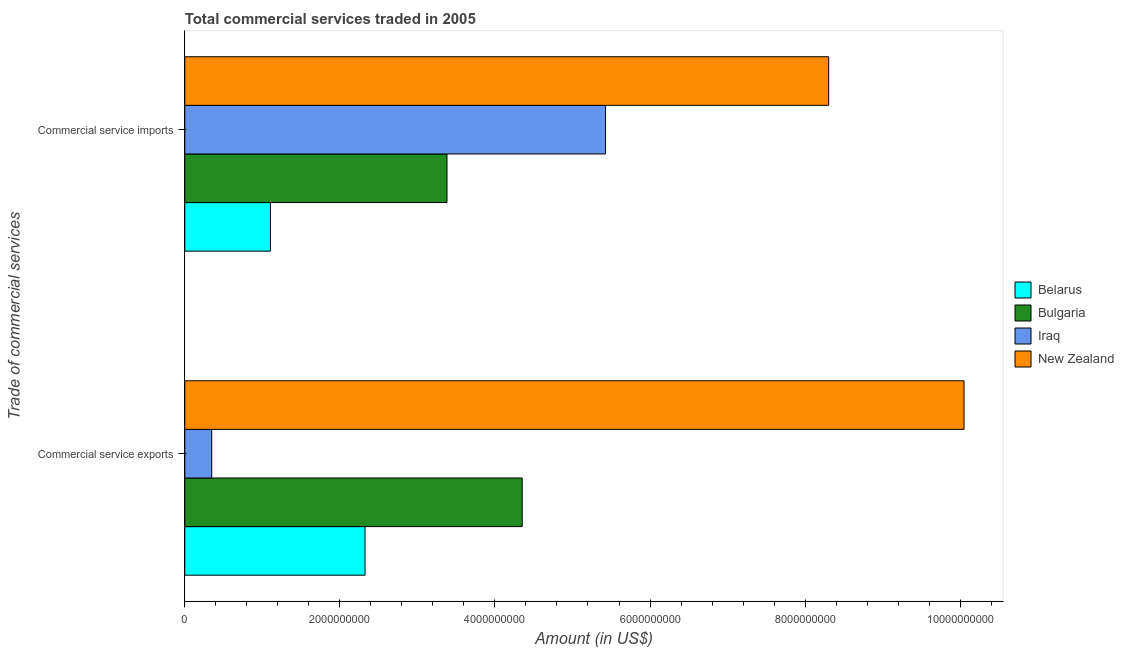How many groups of bars are there?
Offer a terse response. 2. Are the number of bars per tick equal to the number of legend labels?
Provide a succinct answer. Yes. How many bars are there on the 1st tick from the bottom?
Provide a short and direct response. 4. What is the label of the 2nd group of bars from the top?
Keep it short and to the point. Commercial service exports. What is the amount of commercial service imports in Bulgaria?
Make the answer very short. 3.38e+09. Across all countries, what is the maximum amount of commercial service exports?
Make the answer very short. 1.00e+1. Across all countries, what is the minimum amount of commercial service imports?
Your answer should be very brief. 1.10e+09. In which country was the amount of commercial service imports maximum?
Ensure brevity in your answer.  New Zealand. In which country was the amount of commercial service exports minimum?
Keep it short and to the point. Iraq. What is the total amount of commercial service imports in the graph?
Offer a very short reply. 1.82e+1. What is the difference between the amount of commercial service imports in New Zealand and that in Belarus?
Provide a succinct answer. 7.20e+09. What is the difference between the amount of commercial service imports in Bulgaria and the amount of commercial service exports in New Zealand?
Your answer should be very brief. -6.67e+09. What is the average amount of commercial service imports per country?
Offer a very short reply. 4.55e+09. What is the difference between the amount of commercial service imports and amount of commercial service exports in Iraq?
Ensure brevity in your answer.  5.08e+09. In how many countries, is the amount of commercial service exports greater than 4000000000 US$?
Make the answer very short. 2. What is the ratio of the amount of commercial service imports in Iraq to that in Belarus?
Ensure brevity in your answer.  4.91. In how many countries, is the amount of commercial service imports greater than the average amount of commercial service imports taken over all countries?
Offer a very short reply. 2. What does the 4th bar from the top in Commercial service imports represents?
Ensure brevity in your answer.  Belarus. What does the 2nd bar from the bottom in Commercial service exports represents?
Give a very brief answer. Bulgaria. Are all the bars in the graph horizontal?
Provide a short and direct response. Yes. Are the values on the major ticks of X-axis written in scientific E-notation?
Offer a terse response. No. How many legend labels are there?
Your answer should be compact. 4. How are the legend labels stacked?
Give a very brief answer. Vertical. What is the title of the graph?
Your answer should be very brief. Total commercial services traded in 2005. What is the label or title of the X-axis?
Offer a very short reply. Amount (in US$). What is the label or title of the Y-axis?
Keep it short and to the point. Trade of commercial services. What is the Amount (in US$) in Belarus in Commercial service exports?
Provide a short and direct response. 2.32e+09. What is the Amount (in US$) in Bulgaria in Commercial service exports?
Provide a succinct answer. 4.35e+09. What is the Amount (in US$) in Iraq in Commercial service exports?
Provide a succinct answer. 3.48e+08. What is the Amount (in US$) of New Zealand in Commercial service exports?
Keep it short and to the point. 1.00e+1. What is the Amount (in US$) of Belarus in Commercial service imports?
Offer a very short reply. 1.10e+09. What is the Amount (in US$) in Bulgaria in Commercial service imports?
Make the answer very short. 3.38e+09. What is the Amount (in US$) in Iraq in Commercial service imports?
Make the answer very short. 5.43e+09. What is the Amount (in US$) of New Zealand in Commercial service imports?
Your response must be concise. 8.30e+09. Across all Trade of commercial services, what is the maximum Amount (in US$) of Belarus?
Offer a terse response. 2.32e+09. Across all Trade of commercial services, what is the maximum Amount (in US$) of Bulgaria?
Your response must be concise. 4.35e+09. Across all Trade of commercial services, what is the maximum Amount (in US$) in Iraq?
Provide a short and direct response. 5.43e+09. Across all Trade of commercial services, what is the maximum Amount (in US$) in New Zealand?
Offer a very short reply. 1.00e+1. Across all Trade of commercial services, what is the minimum Amount (in US$) in Belarus?
Your response must be concise. 1.10e+09. Across all Trade of commercial services, what is the minimum Amount (in US$) of Bulgaria?
Provide a short and direct response. 3.38e+09. Across all Trade of commercial services, what is the minimum Amount (in US$) of Iraq?
Make the answer very short. 3.48e+08. Across all Trade of commercial services, what is the minimum Amount (in US$) of New Zealand?
Offer a very short reply. 8.30e+09. What is the total Amount (in US$) in Belarus in the graph?
Ensure brevity in your answer.  3.43e+09. What is the total Amount (in US$) of Bulgaria in the graph?
Your answer should be very brief. 7.73e+09. What is the total Amount (in US$) of Iraq in the graph?
Ensure brevity in your answer.  5.77e+09. What is the total Amount (in US$) in New Zealand in the graph?
Keep it short and to the point. 1.84e+1. What is the difference between the Amount (in US$) in Belarus in Commercial service exports and that in Commercial service imports?
Your answer should be very brief. 1.22e+09. What is the difference between the Amount (in US$) of Bulgaria in Commercial service exports and that in Commercial service imports?
Provide a short and direct response. 9.70e+08. What is the difference between the Amount (in US$) in Iraq in Commercial service exports and that in Commercial service imports?
Provide a succinct answer. -5.08e+09. What is the difference between the Amount (in US$) in New Zealand in Commercial service exports and that in Commercial service imports?
Ensure brevity in your answer.  1.75e+09. What is the difference between the Amount (in US$) of Belarus in Commercial service exports and the Amount (in US$) of Bulgaria in Commercial service imports?
Your response must be concise. -1.06e+09. What is the difference between the Amount (in US$) in Belarus in Commercial service exports and the Amount (in US$) in Iraq in Commercial service imports?
Your answer should be very brief. -3.10e+09. What is the difference between the Amount (in US$) in Belarus in Commercial service exports and the Amount (in US$) in New Zealand in Commercial service imports?
Make the answer very short. -5.98e+09. What is the difference between the Amount (in US$) in Bulgaria in Commercial service exports and the Amount (in US$) in Iraq in Commercial service imports?
Provide a succinct answer. -1.07e+09. What is the difference between the Amount (in US$) in Bulgaria in Commercial service exports and the Amount (in US$) in New Zealand in Commercial service imports?
Make the answer very short. -3.95e+09. What is the difference between the Amount (in US$) in Iraq in Commercial service exports and the Amount (in US$) in New Zealand in Commercial service imports?
Offer a terse response. -7.96e+09. What is the average Amount (in US$) in Belarus per Trade of commercial services?
Offer a terse response. 1.71e+09. What is the average Amount (in US$) in Bulgaria per Trade of commercial services?
Ensure brevity in your answer.  3.87e+09. What is the average Amount (in US$) of Iraq per Trade of commercial services?
Offer a terse response. 2.89e+09. What is the average Amount (in US$) in New Zealand per Trade of commercial services?
Your response must be concise. 9.18e+09. What is the difference between the Amount (in US$) of Belarus and Amount (in US$) of Bulgaria in Commercial service exports?
Provide a short and direct response. -2.03e+09. What is the difference between the Amount (in US$) of Belarus and Amount (in US$) of Iraq in Commercial service exports?
Offer a very short reply. 1.98e+09. What is the difference between the Amount (in US$) of Belarus and Amount (in US$) of New Zealand in Commercial service exports?
Offer a terse response. -7.73e+09. What is the difference between the Amount (in US$) in Bulgaria and Amount (in US$) in Iraq in Commercial service exports?
Keep it short and to the point. 4.00e+09. What is the difference between the Amount (in US$) of Bulgaria and Amount (in US$) of New Zealand in Commercial service exports?
Keep it short and to the point. -5.70e+09. What is the difference between the Amount (in US$) of Iraq and Amount (in US$) of New Zealand in Commercial service exports?
Offer a terse response. -9.70e+09. What is the difference between the Amount (in US$) in Belarus and Amount (in US$) in Bulgaria in Commercial service imports?
Your answer should be compact. -2.28e+09. What is the difference between the Amount (in US$) of Belarus and Amount (in US$) of Iraq in Commercial service imports?
Make the answer very short. -4.32e+09. What is the difference between the Amount (in US$) in Belarus and Amount (in US$) in New Zealand in Commercial service imports?
Your answer should be compact. -7.20e+09. What is the difference between the Amount (in US$) in Bulgaria and Amount (in US$) in Iraq in Commercial service imports?
Your answer should be very brief. -2.04e+09. What is the difference between the Amount (in US$) in Bulgaria and Amount (in US$) in New Zealand in Commercial service imports?
Ensure brevity in your answer.  -4.92e+09. What is the difference between the Amount (in US$) of Iraq and Amount (in US$) of New Zealand in Commercial service imports?
Keep it short and to the point. -2.88e+09. What is the ratio of the Amount (in US$) in Belarus in Commercial service exports to that in Commercial service imports?
Provide a succinct answer. 2.11. What is the ratio of the Amount (in US$) of Bulgaria in Commercial service exports to that in Commercial service imports?
Offer a very short reply. 1.29. What is the ratio of the Amount (in US$) of Iraq in Commercial service exports to that in Commercial service imports?
Make the answer very short. 0.06. What is the ratio of the Amount (in US$) in New Zealand in Commercial service exports to that in Commercial service imports?
Provide a succinct answer. 1.21. What is the difference between the highest and the second highest Amount (in US$) of Belarus?
Your answer should be compact. 1.22e+09. What is the difference between the highest and the second highest Amount (in US$) in Bulgaria?
Keep it short and to the point. 9.70e+08. What is the difference between the highest and the second highest Amount (in US$) of Iraq?
Your response must be concise. 5.08e+09. What is the difference between the highest and the second highest Amount (in US$) of New Zealand?
Offer a very short reply. 1.75e+09. What is the difference between the highest and the lowest Amount (in US$) of Belarus?
Your answer should be compact. 1.22e+09. What is the difference between the highest and the lowest Amount (in US$) in Bulgaria?
Make the answer very short. 9.70e+08. What is the difference between the highest and the lowest Amount (in US$) of Iraq?
Give a very brief answer. 5.08e+09. What is the difference between the highest and the lowest Amount (in US$) of New Zealand?
Offer a very short reply. 1.75e+09. 